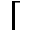<formula> <loc_0><loc_0><loc_500><loc_500>\lceil</formula> 